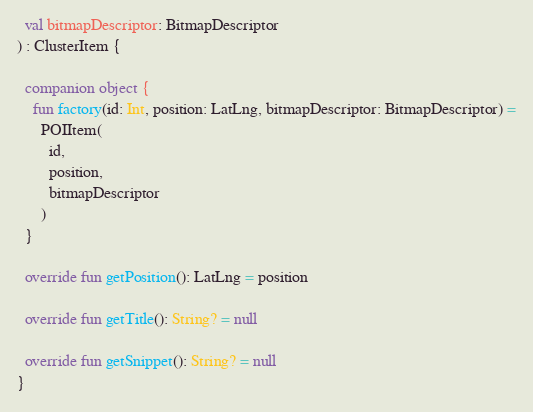Convert code to text. <code><loc_0><loc_0><loc_500><loc_500><_Kotlin_>  val bitmapDescriptor: BitmapDescriptor
) : ClusterItem {

  companion object {
    fun factory(id: Int, position: LatLng, bitmapDescriptor: BitmapDescriptor) =
      POIItem(
        id,
        position,
        bitmapDescriptor
      )
  }

  override fun getPosition(): LatLng = position

  override fun getTitle(): String? = null

  override fun getSnippet(): String? = null
}
</code> 